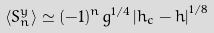Convert formula to latex. <formula><loc_0><loc_0><loc_500><loc_500>\left \langle S _ { n } ^ { y } \right \rangle \simeq ( - 1 ) ^ { n } g ^ { 1 / 4 } \left | h _ { c } - h \right | ^ { 1 / 8 }</formula> 